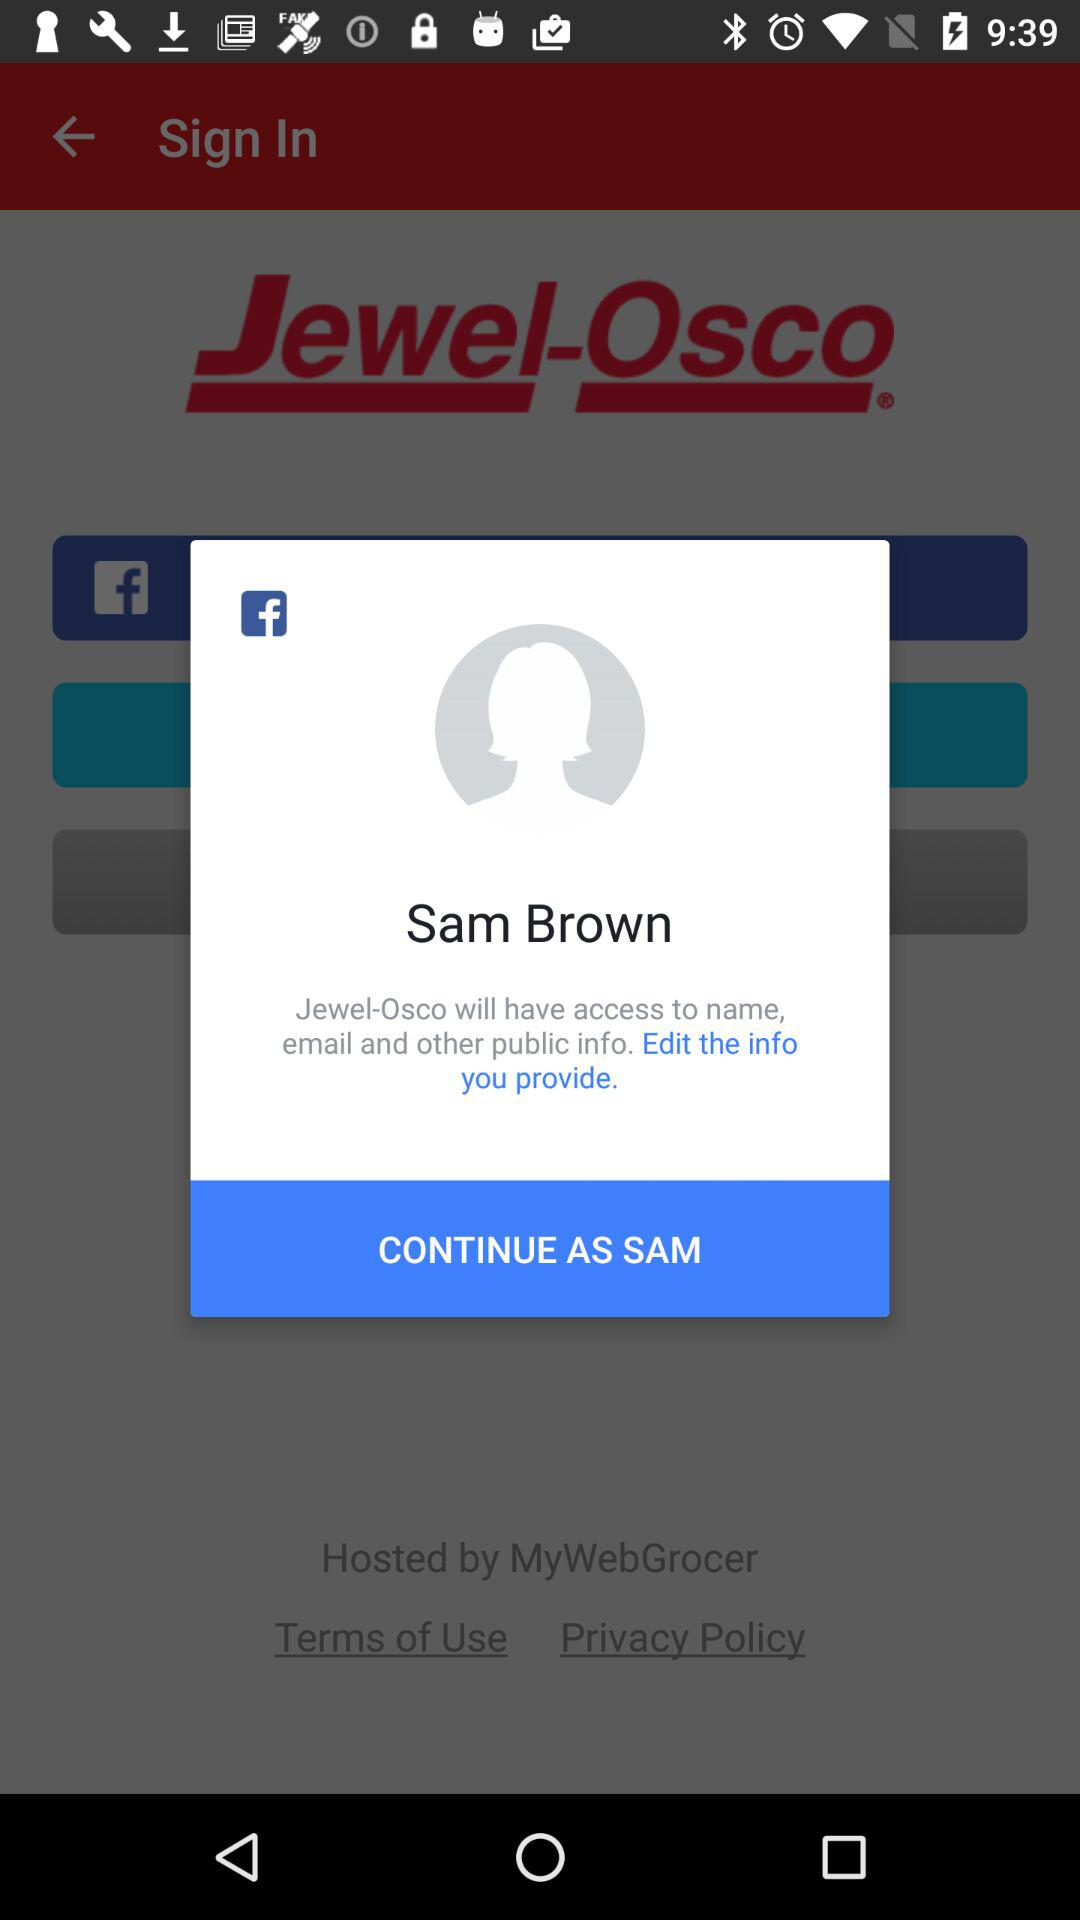Through what app can we continue? You can continue through "Facebook". 